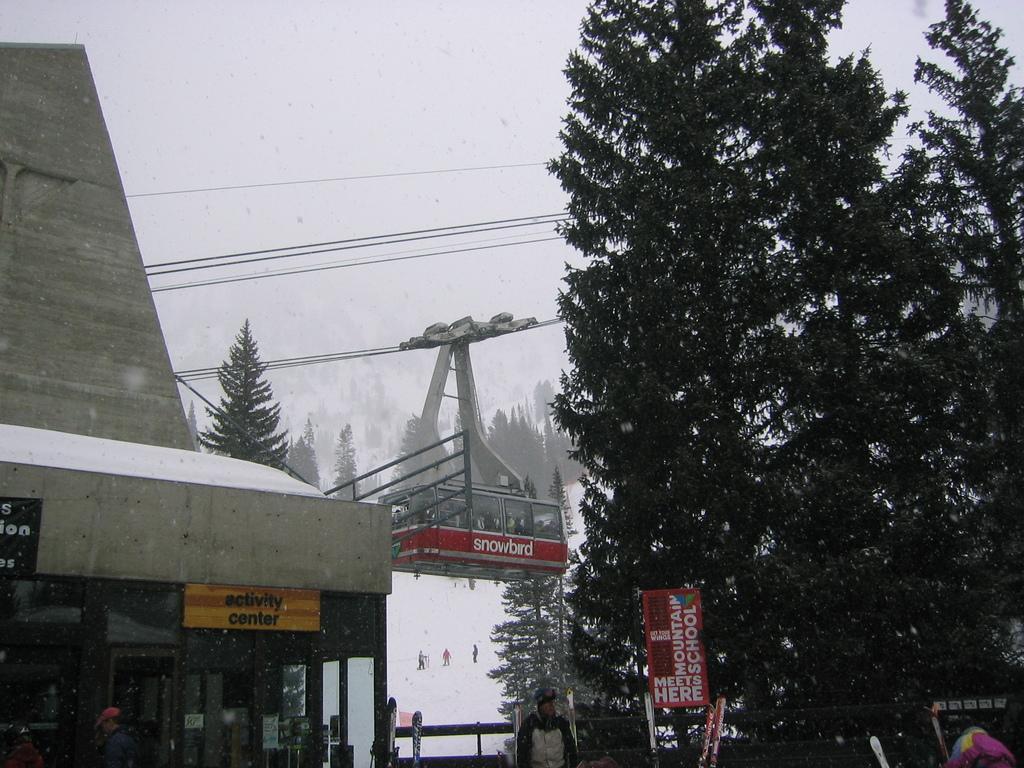Please provide a concise description of this image. In this image I can see few trees which are green in color, few persons standing, a red and white colored board, a building and a cable car. I can see snow on the ground, number of persons standing on the snow, few trees, few wires and the sky in the background. 